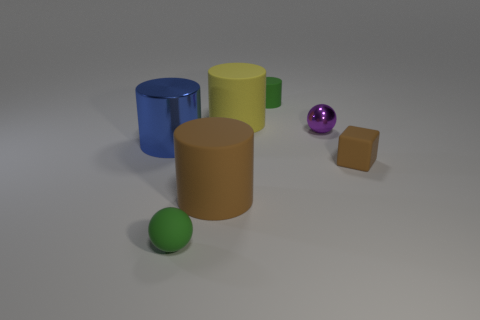Is there a pattern to the distribution of colors among the objects? While there isn't a strict pattern, the distribution of colors is balanced, with the brighter yellow cylinder providing a central focal point, surrounded by objects in more muted tones like green, brown, and blue, which complement each other and create a harmonious visual experience. How do the different materials of the objects affect the visual texture of the image? The varying materials create a diversity of surfaces, with the matte cylinders offering a soft and even texture, the shiny sphere reflecting light and catching the eye, and the rubber block providing a slightly rough and granular texture, together producing a subtle interplay of visual textures. 